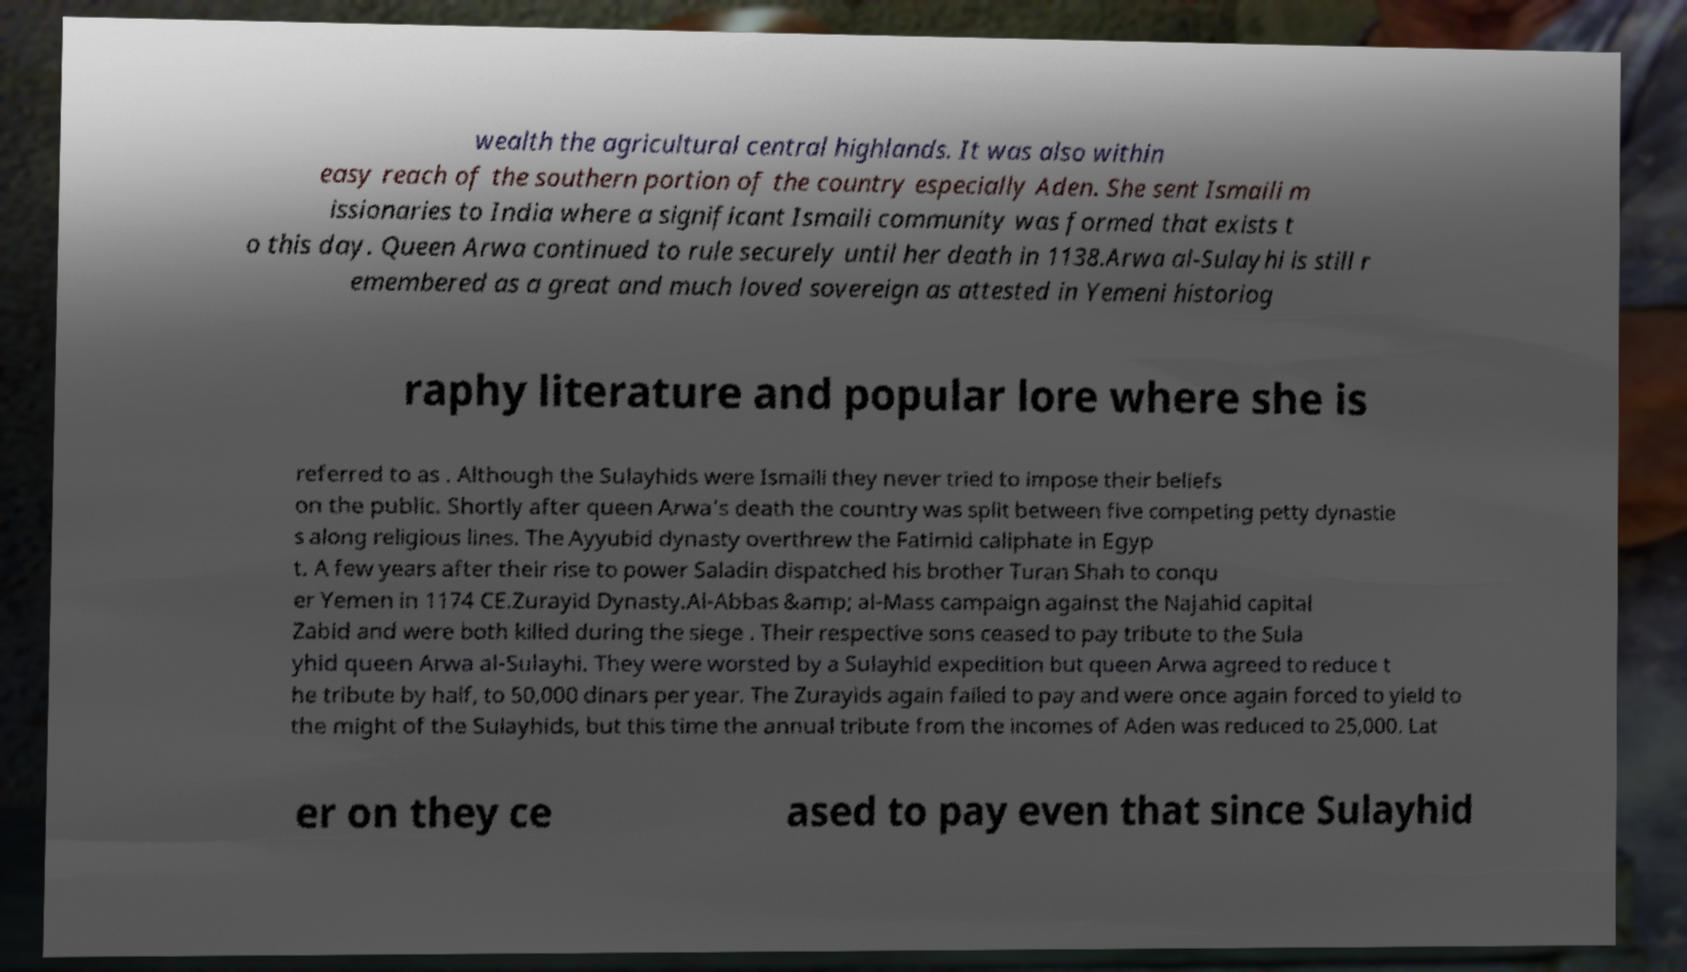I need the written content from this picture converted into text. Can you do that? wealth the agricultural central highlands. It was also within easy reach of the southern portion of the country especially Aden. She sent Ismaili m issionaries to India where a significant Ismaili community was formed that exists t o this day. Queen Arwa continued to rule securely until her death in 1138.Arwa al-Sulayhi is still r emembered as a great and much loved sovereign as attested in Yemeni historiog raphy literature and popular lore where she is referred to as . Although the Sulayhids were Ismaili they never tried to impose their beliefs on the public. Shortly after queen Arwa's death the country was split between five competing petty dynastie s along religious lines. The Ayyubid dynasty overthrew the Fatimid caliphate in Egyp t. A few years after their rise to power Saladin dispatched his brother Turan Shah to conqu er Yemen in 1174 CE.Zurayid Dynasty.Al-Abbas &amp; al-Mass campaign against the Najahid capital Zabid and were both killed during the siege . Their respective sons ceased to pay tribute to the Sula yhid queen Arwa al-Sulayhi. They were worsted by a Sulayhid expedition but queen Arwa agreed to reduce t he tribute by half, to 50,000 dinars per year. The Zurayids again failed to pay and were once again forced to yield to the might of the Sulayhids, but this time the annual tribute from the incomes of Aden was reduced to 25,000. Lat er on they ce ased to pay even that since Sulayhid 